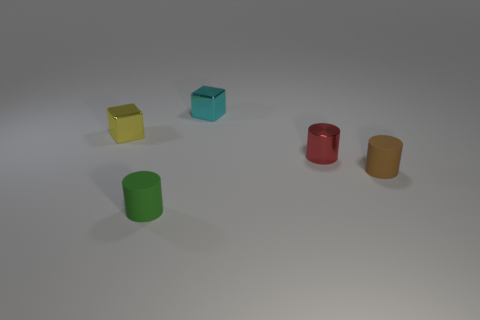How many objects are cyan cubes or small things that are in front of the small metal cylinder?
Your answer should be very brief. 3. How many purple objects are rubber cylinders or blocks?
Your answer should be very brief. 0. Are there any cyan shiny things left of the small cylinder that is in front of the tiny rubber object on the right side of the tiny cyan metallic block?
Keep it short and to the point. No. Are there any other things that have the same size as the yellow block?
Offer a very short reply. Yes. What color is the tiny cylinder that is to the right of the shiny object that is to the right of the cyan metal object?
Keep it short and to the point. Brown. How many small objects are either green objects or yellow balls?
Make the answer very short. 1. There is a object that is both in front of the tiny red cylinder and on the right side of the tiny cyan object; what is its color?
Provide a short and direct response. Brown. Is the small yellow thing made of the same material as the red cylinder?
Your response must be concise. Yes. There is a yellow object; what shape is it?
Your answer should be compact. Cube. How many small blocks are behind the small cube on the left side of the tiny metallic cube that is to the right of the yellow shiny thing?
Make the answer very short. 1. 